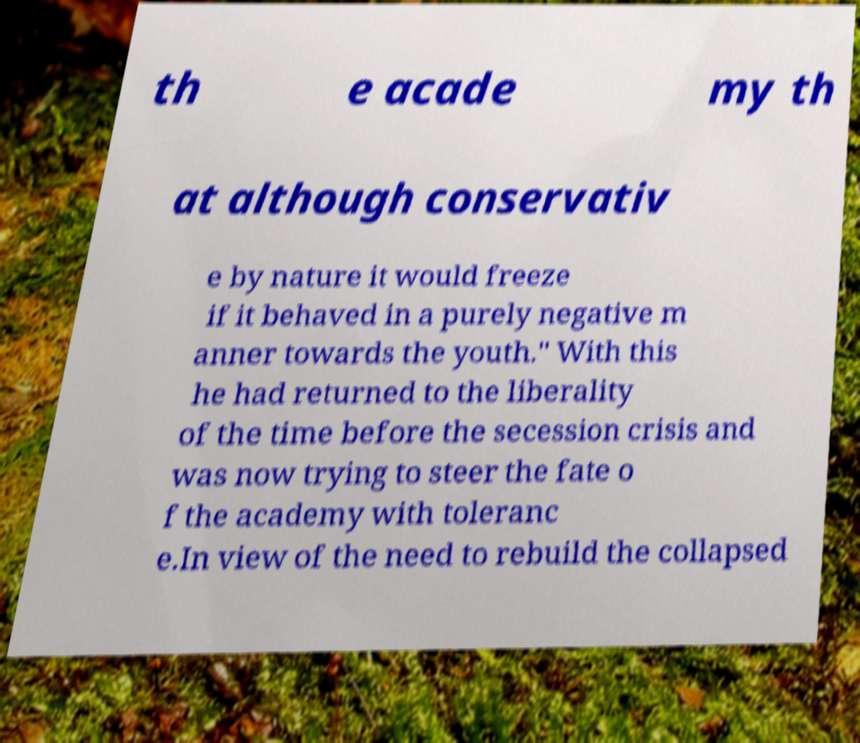Could you assist in decoding the text presented in this image and type it out clearly? th e acade my th at although conservativ e by nature it would freeze if it behaved in a purely negative m anner towards the youth." With this he had returned to the liberality of the time before the secession crisis and was now trying to steer the fate o f the academy with toleranc e.In view of the need to rebuild the collapsed 